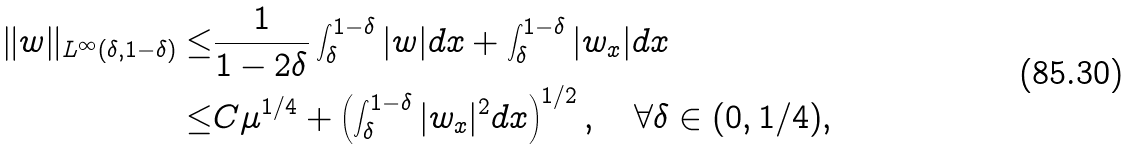<formula> <loc_0><loc_0><loc_500><loc_500>\| w \| _ { L ^ { \infty } ( \delta , 1 - \delta ) } \leq & \frac { 1 } { 1 - 2 \delta } \int _ { \delta } ^ { 1 - \delta } | w | d x + \int _ { \delta } ^ { 1 - \delta } | w _ { x } | d x \\ \leq & C \mu ^ { 1 / 4 } + \left ( \int _ { \delta } ^ { 1 - \delta } | w _ { x } | ^ { 2 } d x \right ) ^ { 1 / 2 } , \quad \forall \delta \in ( 0 , 1 / 4 ) ,</formula> 